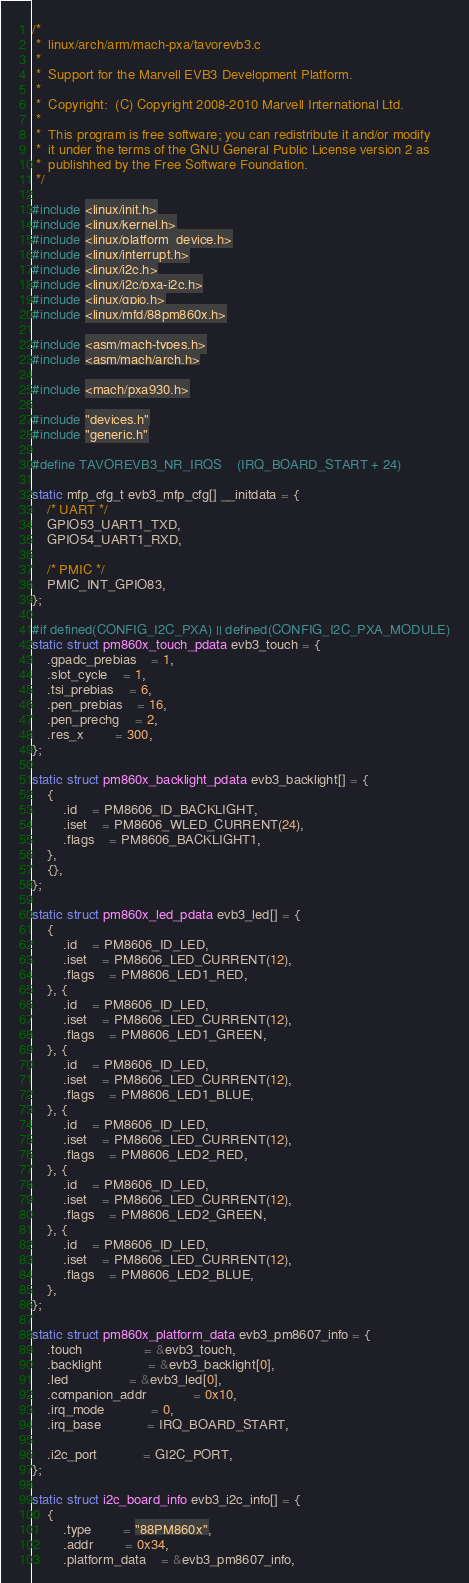<code> <loc_0><loc_0><loc_500><loc_500><_C_>/*
 *  linux/arch/arm/mach-pxa/tavorevb3.c
 *
 *  Support for the Marvell EVB3 Development Platform.
 *
 *  Copyright:  (C) Copyright 2008-2010 Marvell International Ltd.
 *
 *  This program is free software; you can redistribute it and/or modify
 *  it under the terms of the GNU General Public License version 2 as
 *  publishhed by the Free Software Foundation.
 */

#include <linux/init.h>
#include <linux/kernel.h>
#include <linux/platform_device.h>
#include <linux/interrupt.h>
#include <linux/i2c.h>
#include <linux/i2c/pxa-i2c.h>
#include <linux/gpio.h>
#include <linux/mfd/88pm860x.h>

#include <asm/mach-types.h>
#include <asm/mach/arch.h>

#include <mach/pxa930.h>

#include "devices.h"
#include "generic.h"

#define TAVOREVB3_NR_IRQS	(IRQ_BOARD_START + 24)

static mfp_cfg_t evb3_mfp_cfg[] __initdata = {
	/* UART */
	GPIO53_UART1_TXD,
	GPIO54_UART1_RXD,

	/* PMIC */
	PMIC_INT_GPIO83,
};

#if defined(CONFIG_I2C_PXA) || defined(CONFIG_I2C_PXA_MODULE)
static struct pm860x_touch_pdata evb3_touch = {
	.gpadc_prebias	= 1,
	.slot_cycle	= 1,
	.tsi_prebias	= 6,
	.pen_prebias	= 16,
	.pen_prechg	= 2,
	.res_x		= 300,
};

static struct pm860x_backlight_pdata evb3_backlight[] = {
	{
		.id	= PM8606_ID_BACKLIGHT,
		.iset	= PM8606_WLED_CURRENT(24),
		.flags	= PM8606_BACKLIGHT1,
	},
	{},
};

static struct pm860x_led_pdata evb3_led[] = {
	{
		.id	= PM8606_ID_LED,
		.iset	= PM8606_LED_CURRENT(12),
		.flags	= PM8606_LED1_RED,
	}, {
		.id	= PM8606_ID_LED,
		.iset	= PM8606_LED_CURRENT(12),
		.flags	= PM8606_LED1_GREEN,
	}, {
		.id	= PM8606_ID_LED,
		.iset	= PM8606_LED_CURRENT(12),
		.flags	= PM8606_LED1_BLUE,
	}, {
		.id	= PM8606_ID_LED,
		.iset	= PM8606_LED_CURRENT(12),
		.flags	= PM8606_LED2_RED,
	}, {
		.id	= PM8606_ID_LED,
		.iset	= PM8606_LED_CURRENT(12),
		.flags	= PM8606_LED2_GREEN,
	}, {
		.id	= PM8606_ID_LED,
		.iset	= PM8606_LED_CURRENT(12),
		.flags	= PM8606_LED2_BLUE,
	},
};

static struct pm860x_platform_data evb3_pm8607_info = {
	.touch				= &evb3_touch,
	.backlight			= &evb3_backlight[0],
	.led				= &evb3_led[0],
	.companion_addr			= 0x10,
	.irq_mode			= 0,
	.irq_base			= IRQ_BOARD_START,

	.i2c_port			= GI2C_PORT,
};

static struct i2c_board_info evb3_i2c_info[] = {
	{
		.type		= "88PM860x",
		.addr		= 0x34,
		.platform_data	= &evb3_pm8607_info,</code> 